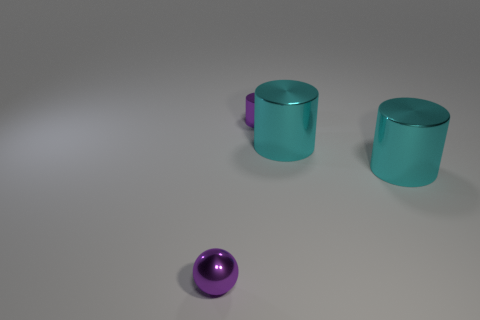The small metallic cylinder to the right of the tiny object that is in front of the small thing behind the tiny purple sphere is what color?
Offer a terse response. Purple. Do the small ball and the purple cylinder have the same material?
Your response must be concise. Yes. Are there the same number of cyan shiny objects on the left side of the purple shiny cylinder and cylinders that are in front of the tiny purple sphere?
Offer a very short reply. Yes. There is a small cylinder that is made of the same material as the purple ball; what color is it?
Your response must be concise. Purple. What number of purple cylinders have the same material as the purple sphere?
Ensure brevity in your answer.  1. There is a small shiny object in front of the purple cylinder; is it the same color as the tiny cylinder?
Your answer should be compact. Yes. Are there an equal number of large cyan shiny cylinders that are behind the purple metallic cylinder and large things?
Offer a very short reply. No. There is a thing that is the same size as the purple metallic cylinder; what color is it?
Provide a succinct answer. Purple. What material is the purple thing that is behind the small metallic thing that is left of the purple cylinder behind the purple shiny ball made of?
Your answer should be compact. Metal. How many other things are there of the same size as the purple metal cylinder?
Offer a very short reply. 1. 